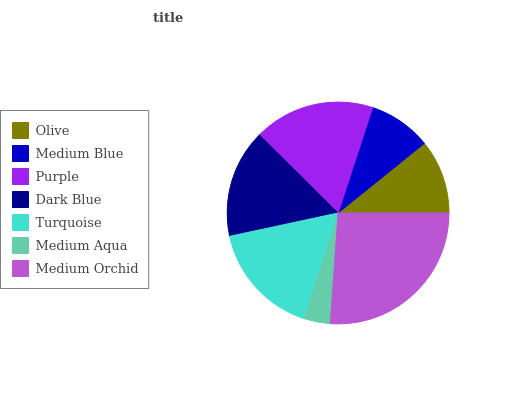Is Medium Aqua the minimum?
Answer yes or no. Yes. Is Medium Orchid the maximum?
Answer yes or no. Yes. Is Medium Blue the minimum?
Answer yes or no. No. Is Medium Blue the maximum?
Answer yes or no. No. Is Olive greater than Medium Blue?
Answer yes or no. Yes. Is Medium Blue less than Olive?
Answer yes or no. Yes. Is Medium Blue greater than Olive?
Answer yes or no. No. Is Olive less than Medium Blue?
Answer yes or no. No. Is Dark Blue the high median?
Answer yes or no. Yes. Is Dark Blue the low median?
Answer yes or no. Yes. Is Medium Aqua the high median?
Answer yes or no. No. Is Turquoise the low median?
Answer yes or no. No. 